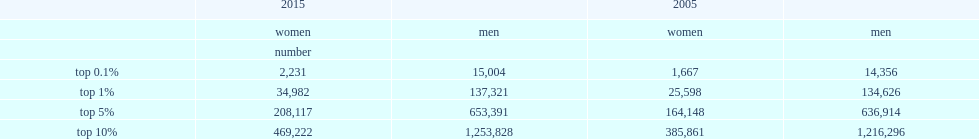What was the number of women and men included in the top 1% in 2015 respectively? 34982.0 137321.0. What was the percentage of women in the top 1% in 2005? 0.159764. What was the number of women and men in the top 0.1% in 2015 respectively? 2231.0 15004.0. 